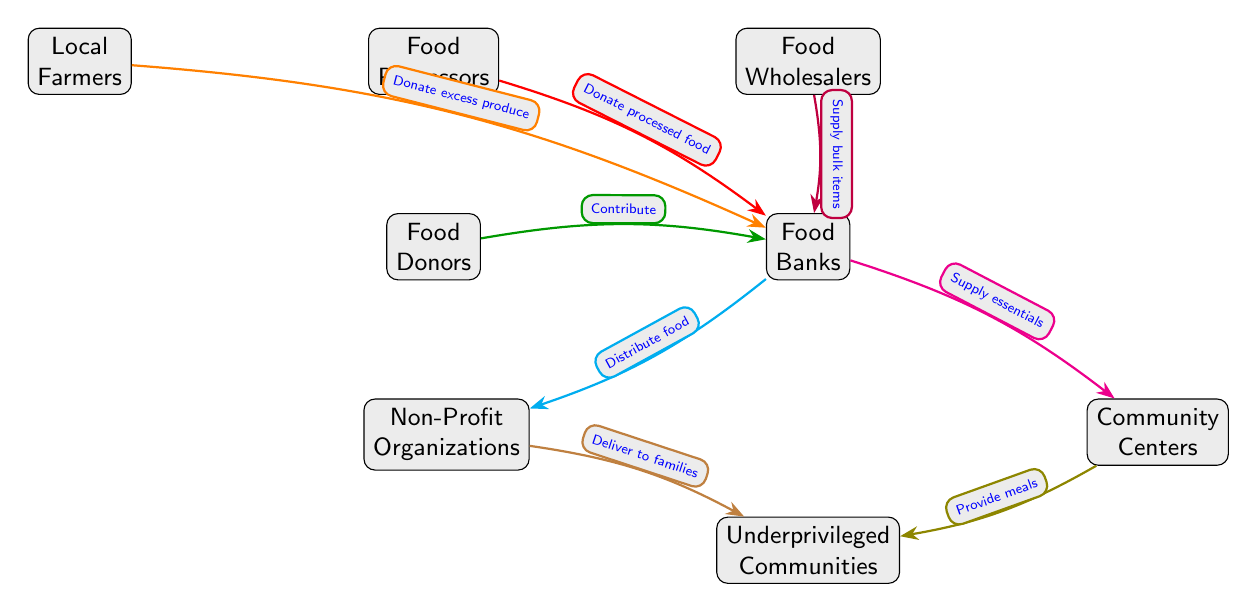What do local farmers donate to food banks? Local farmers donate excess produce to food banks, as indicated by the arrow connecting them in the diagram.
Answer: excess produce What is one type of donation from food processors to food banks? Food processors donate processed food to food banks, which is shown by the directed arrow between these nodes in the diagram.
Answer: processed food How many main sources contribute to food banks? The diagram shows four main sources contributing to food banks: local farmers, food processors, food wholesalers, and food donors. Counting these sources gives us a total of four.
Answer: 4 What do NGOs deliver to underprivileged communities? NGOs deliver meals to underprivileged communities, as indicated by the arrow connecting NGOs to the underprivileged communities node in the diagram.
Answer: meals What relationship is there between food banks and community centers? Food banks supply essentials to community centers, as shown by the directed arrow from food banks to community centers in the diagram.
Answer: supply essentials Which node is located below food banks? Beneath the food banks node, the diagram displays two nodes: non-profit organizations and community centers. The first one listed, non-profit organizations, is the one directly below food banks.
Answer: Non-Profit Organizations How does food reach underprivileged communities from food banks? Food reaches underprivileged communities through two pathways: NGOs deliver food items, and community centers provide meals, which are both illustrated by the arrows leading from food banks to these nodes.
Answer: NGOs and Community Centers What action do food wholesalers take towards food banks? Food wholesalers supply bulk items to food banks, which is explicitly indicated by the directed arrow going from food wholesalers to food banks.
Answer: Supply bulk items What is the overall purpose of food banks in the diagram? The overall purpose of food banks is to act as distribution channels for food from donors and suppliers to underprivileged communities, as seen in the connections among the nodes.
Answer: Distribution channels 